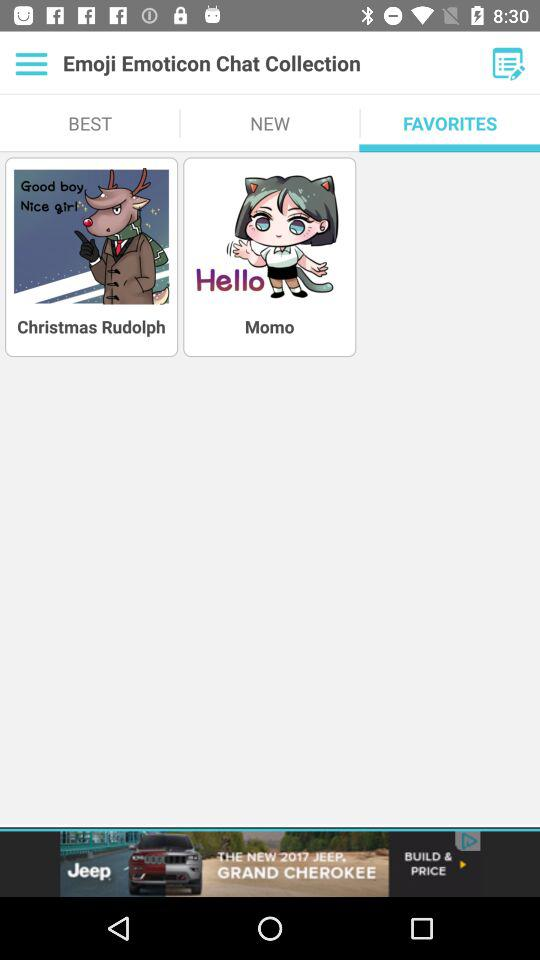Which item has a longer name, Christmas Rudolph or Momo?
Answer the question using a single word or phrase. Christmas Rudolph 